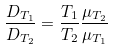<formula> <loc_0><loc_0><loc_500><loc_500>\frac { D _ { T _ { 1 } } } { D _ { T _ { 2 } } } = \frac { T _ { 1 } } { T _ { 2 } } \frac { \mu _ { T _ { 2 } } } { \mu _ { T _ { 1 } } }</formula> 